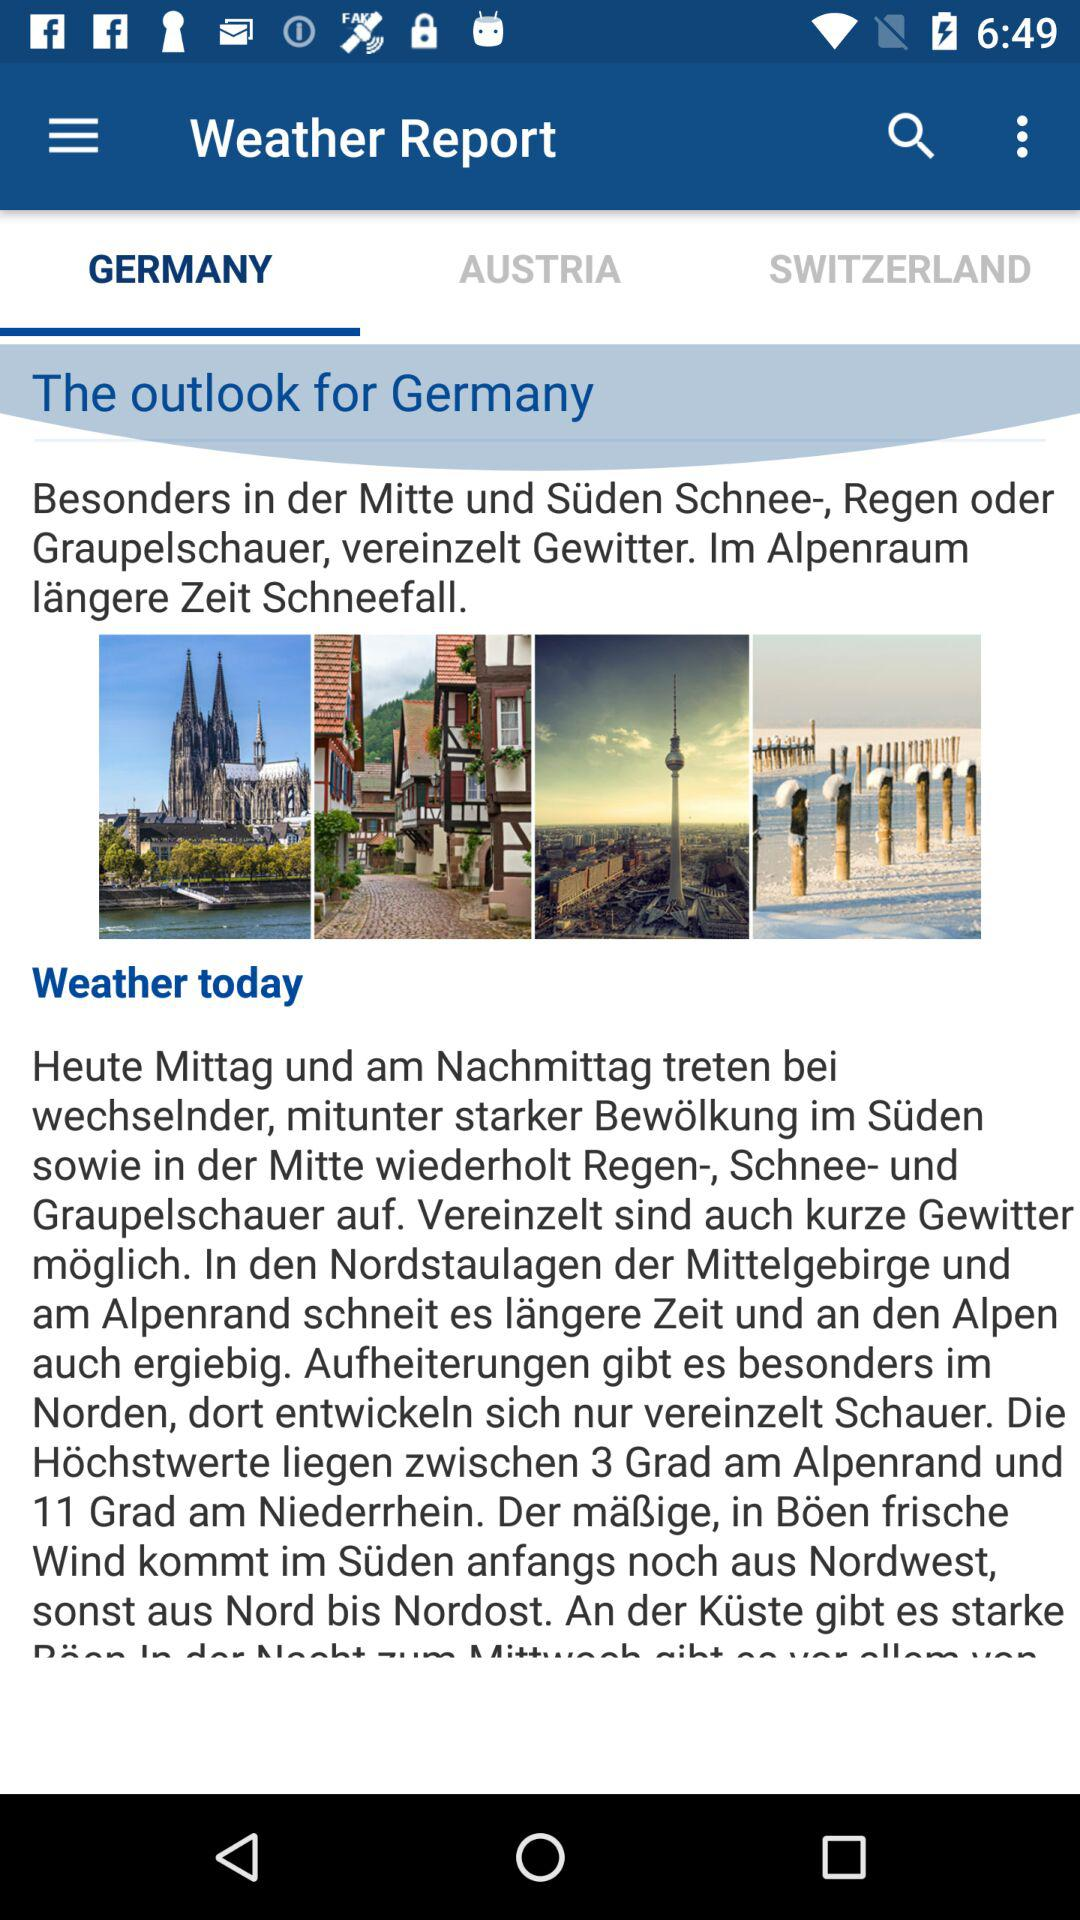What is the application name? The application name is "Weather Report". 